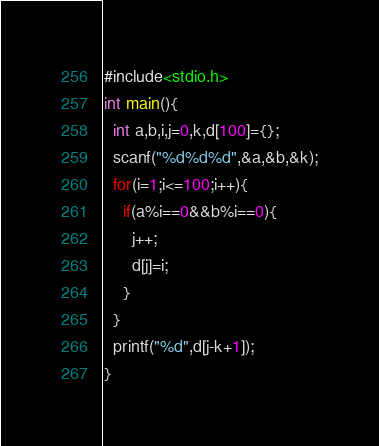Convert code to text. <code><loc_0><loc_0><loc_500><loc_500><_C_>#include<stdio.h>
int main(){
  int a,b,i,j=0,k,d[100]={};
  scanf("%d%d%d",&a,&b,&k);
  for(i=1;i<=100;i++){
    if(a%i==0&&b%i==0){
      j++;
      d[j]=i;
    }
  }
  printf("%d",d[j-k+1]);
}</code> 